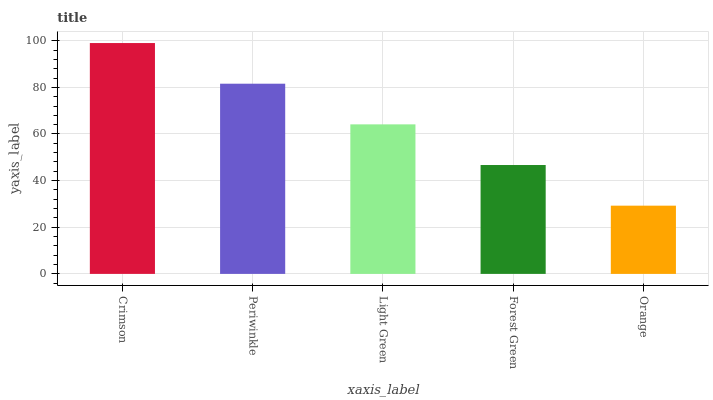Is Orange the minimum?
Answer yes or no. Yes. Is Crimson the maximum?
Answer yes or no. Yes. Is Periwinkle the minimum?
Answer yes or no. No. Is Periwinkle the maximum?
Answer yes or no. No. Is Crimson greater than Periwinkle?
Answer yes or no. Yes. Is Periwinkle less than Crimson?
Answer yes or no. Yes. Is Periwinkle greater than Crimson?
Answer yes or no. No. Is Crimson less than Periwinkle?
Answer yes or no. No. Is Light Green the high median?
Answer yes or no. Yes. Is Light Green the low median?
Answer yes or no. Yes. Is Orange the high median?
Answer yes or no. No. Is Orange the low median?
Answer yes or no. No. 